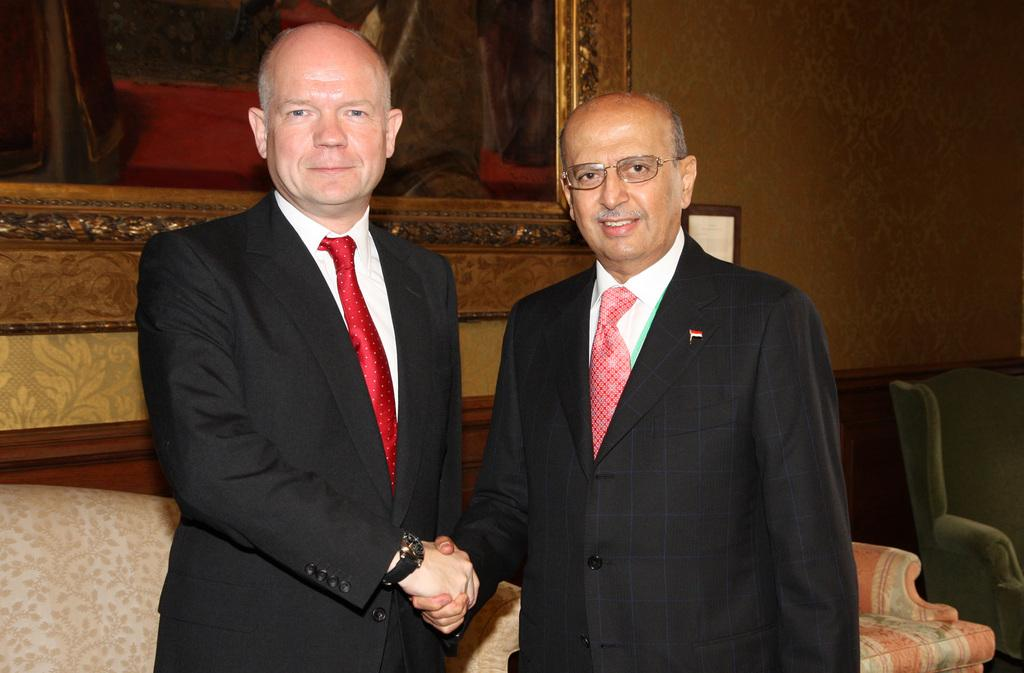What are the men in the image wearing? The men are wearing formal suits, wrist watches, and ties. What can be seen on the wall in the image? There is a photo frame on the wall in the image. What is on the ground in the image? There is soda on the ground in the image. What type of bag is the man carrying in the image? There is no bag visible in the image; the men are only wearing formal suits, wrist watches, and ties. What is the man doing with his head in the image? There is no specific action involving the men's heads mentioned in the image; they are simply standing and wearing formal attire. 